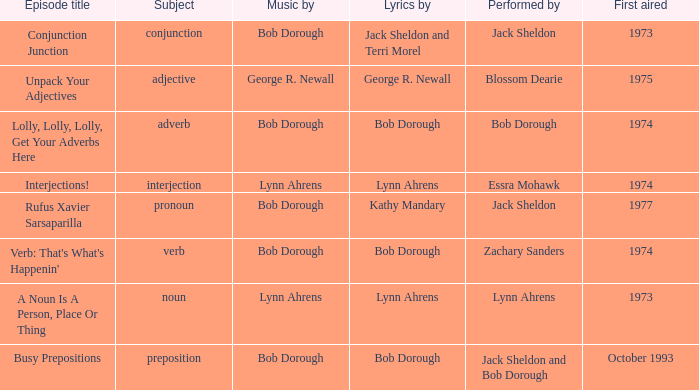When zachary sanders is the performer how many people is the music by? 1.0. 